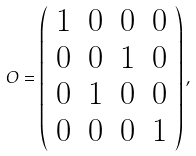<formula> <loc_0><loc_0><loc_500><loc_500>O = \left ( \begin{array} { c c c c } 1 & 0 & 0 & 0 \\ 0 & 0 & 1 & 0 \\ 0 & 1 & 0 & 0 \\ 0 & 0 & 0 & 1 \end{array} \right ) ,</formula> 